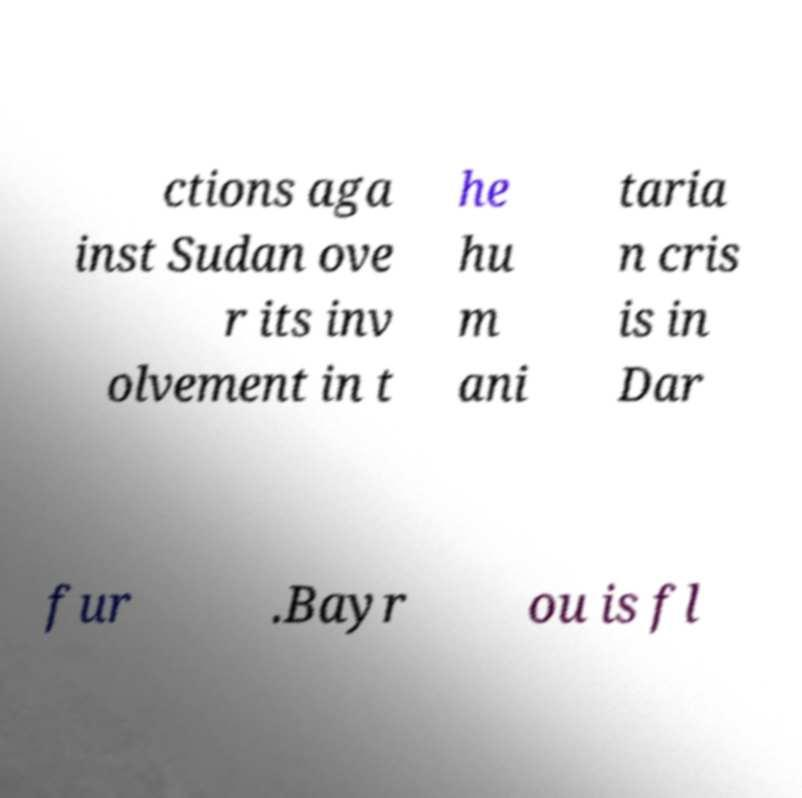Please read and relay the text visible in this image. What does it say? ctions aga inst Sudan ove r its inv olvement in t he hu m ani taria n cris is in Dar fur .Bayr ou is fl 